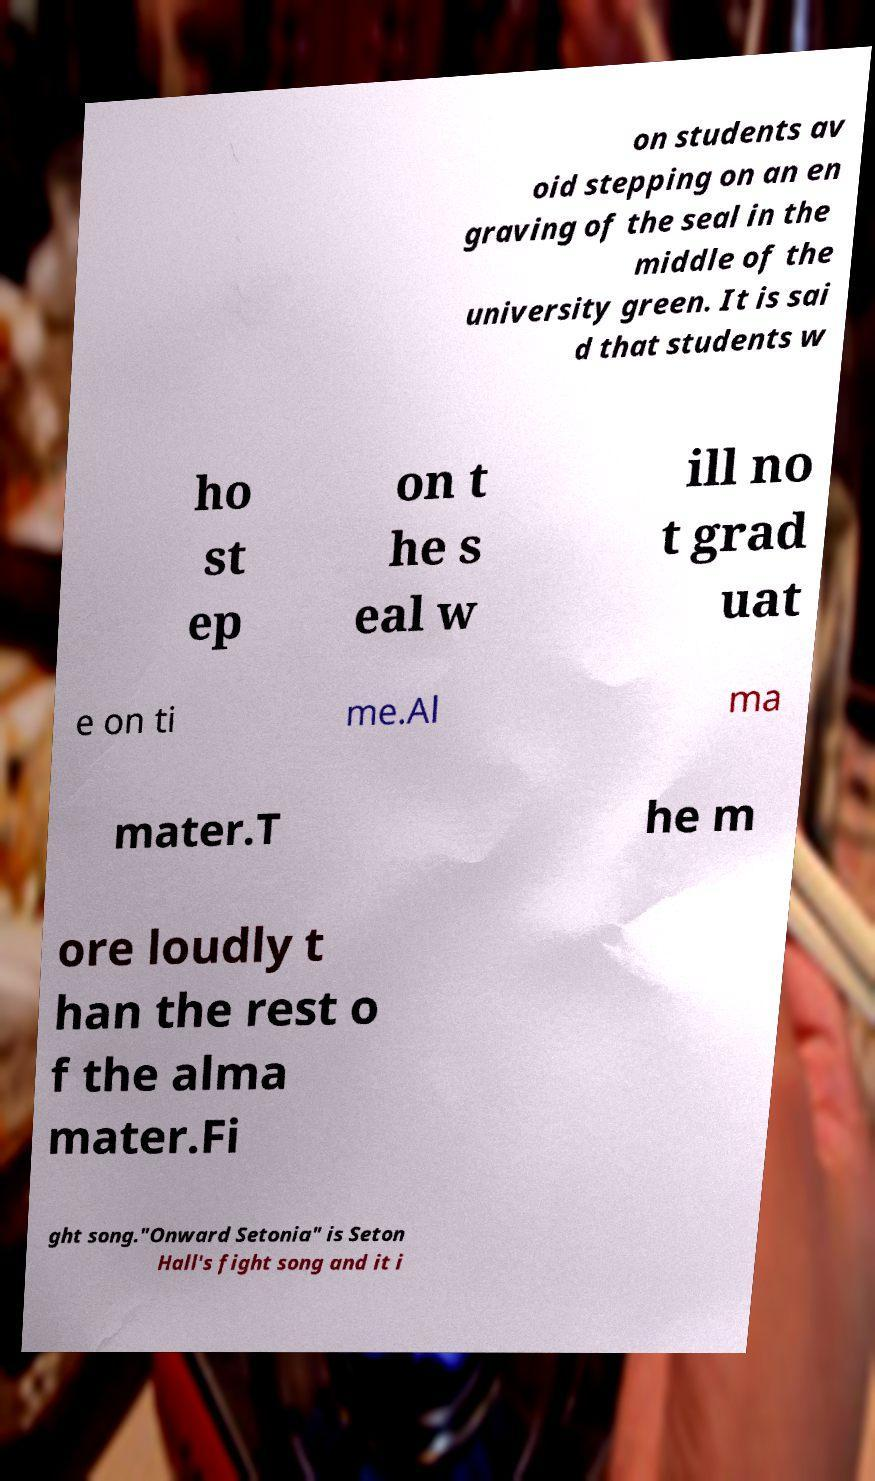Please read and relay the text visible in this image. What does it say? on students av oid stepping on an en graving of the seal in the middle of the university green. It is sai d that students w ho st ep on t he s eal w ill no t grad uat e on ti me.Al ma mater.T he m ore loudly t han the rest o f the alma mater.Fi ght song."Onward Setonia" is Seton Hall's fight song and it i 